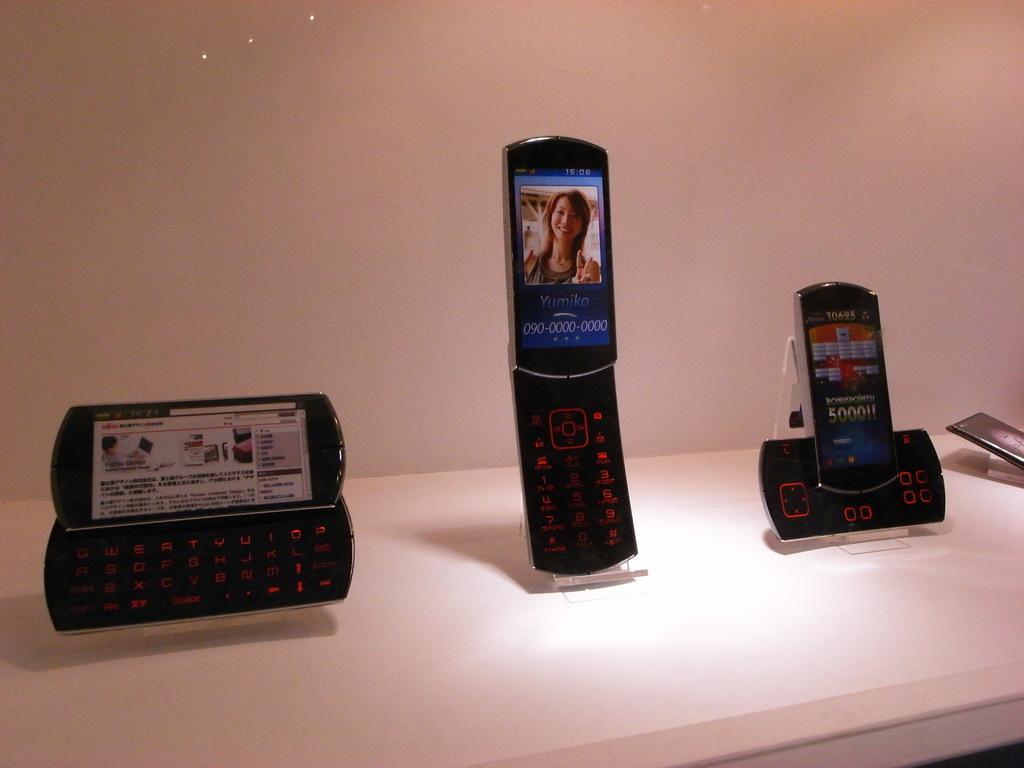Can you describe this image briefly? On this white surface we can four mobiles. 